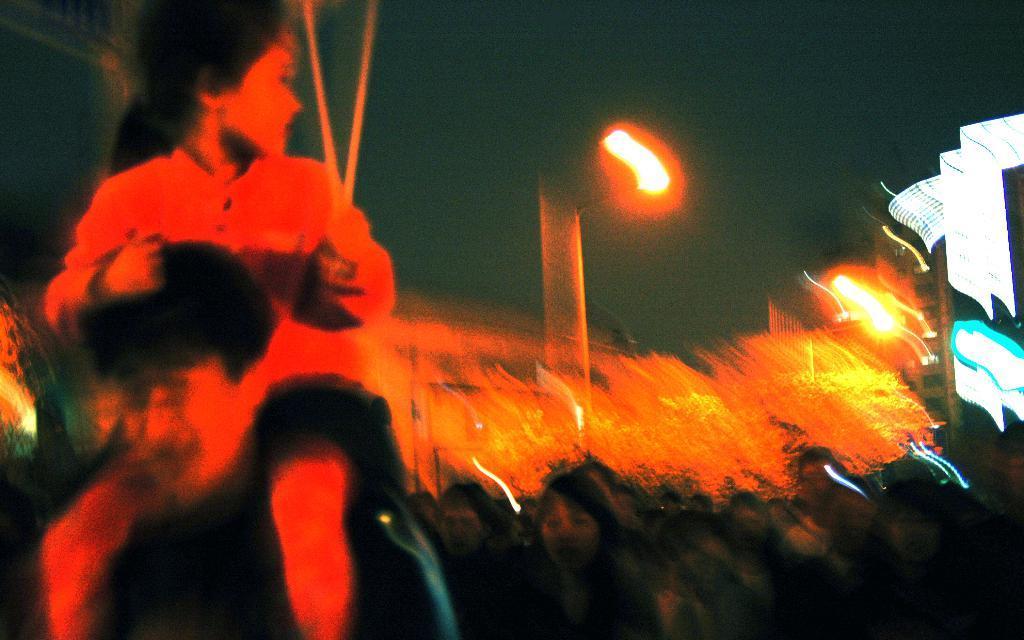Describe this image in one or two sentences. This is a blur image. In this image, on the left side, we can see two people, on the right side, we can see two group of people, buildings, lights. At the top, we can see a sky. 